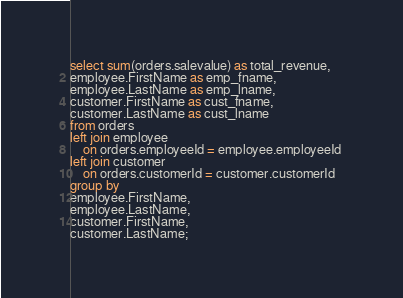<code> <loc_0><loc_0><loc_500><loc_500><_SQL_>select sum(orders.salevalue) as total_revenue,
employee.FirstName as emp_fname, 
employee.LastName as emp_lname, 
customer.FirstName as cust_fname, 
customer.LastName as cust_lname 
from orders 
left join employee
	on orders.employeeId = employee.employeeId 
left join customer 
	on orders.customerId = customer.customerId
group by
employee.FirstName, 
employee.LastName, 
customer.FirstName, 
customer.LastName;</code> 